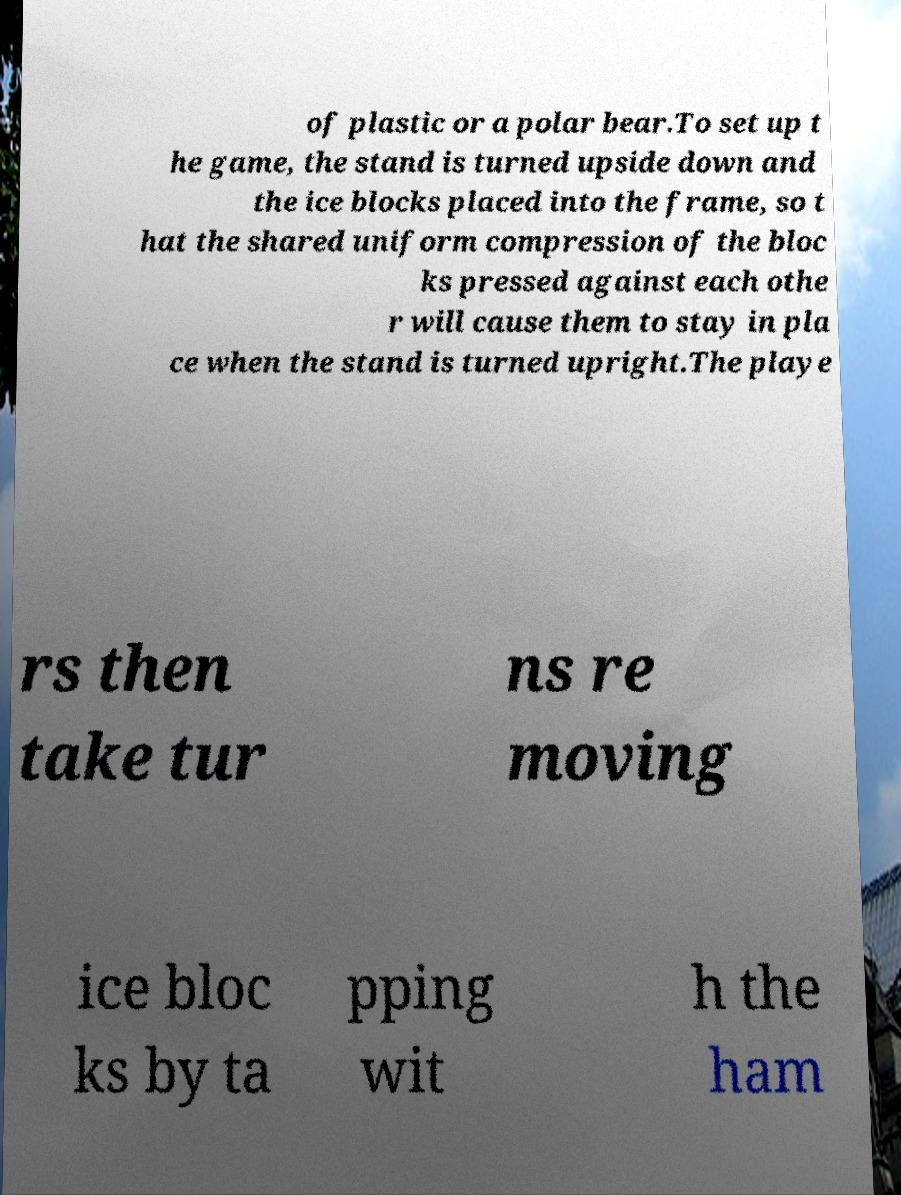Can you read and provide the text displayed in the image?This photo seems to have some interesting text. Can you extract and type it out for me? of plastic or a polar bear.To set up t he game, the stand is turned upside down and the ice blocks placed into the frame, so t hat the shared uniform compression of the bloc ks pressed against each othe r will cause them to stay in pla ce when the stand is turned upright.The playe rs then take tur ns re moving ice bloc ks by ta pping wit h the ham 